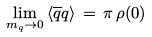<formula> <loc_0><loc_0><loc_500><loc_500>\lim _ { m _ { q } \rightarrow 0 } \, \langle \overline { q } q \rangle \, = \, \pi \, \rho ( 0 )</formula> 